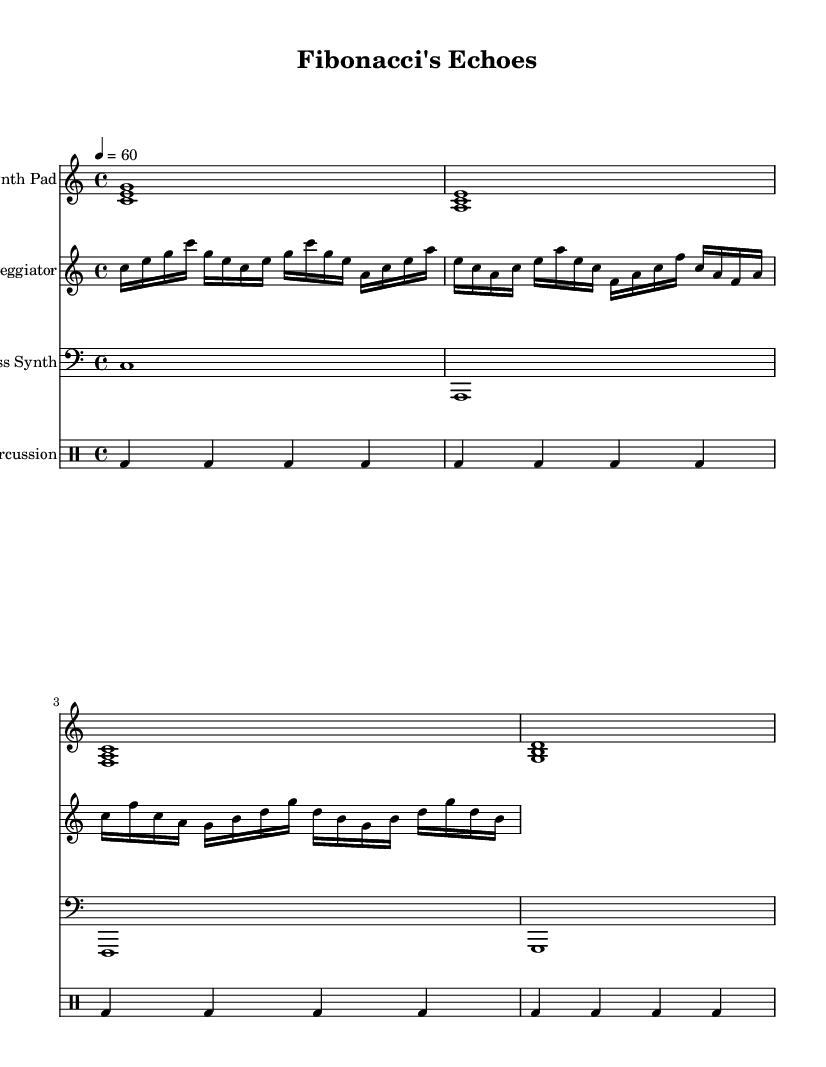What is the key signature of this music? The key signature is C major, which has no sharps or flats.
Answer: C major What is the time signature of the piece? The time signature is indicated by the notation at the beginning, showing 4 beats per measure.
Answer: 4/4 What is the tempo marking for this composition? The tempo marking indicates a quarter note equals 60 beats per minute, meaning a slow and steady pace.
Answer: 60 How many measures are there in the "Synth Pad" part? By counting the number of vertical bar lines in the "Synth Pad" part, there are 4 measures total.
Answer: 4 What type of instrument is represented by the "Bass Synth" staff? The "Bass Synth" is labeled as the bass clef and indicates a low-frequency sound typical in electronic music.
Answer: Bass Synth How does the arpeggiator relate to the chords played by the synth pad? The arpeggiator plays broken chords that correspond to the synth pad's sustained chords, demonstrating a layering technique common in ambient electronic music.
Answer: Layering technique What rhythmic pattern is used in the percussion part? The percussion pattern consists primarily of repeated bass drum hits on each beat, creating a steady pulse throughout the piece.
Answer: Repeated bass drum hits 